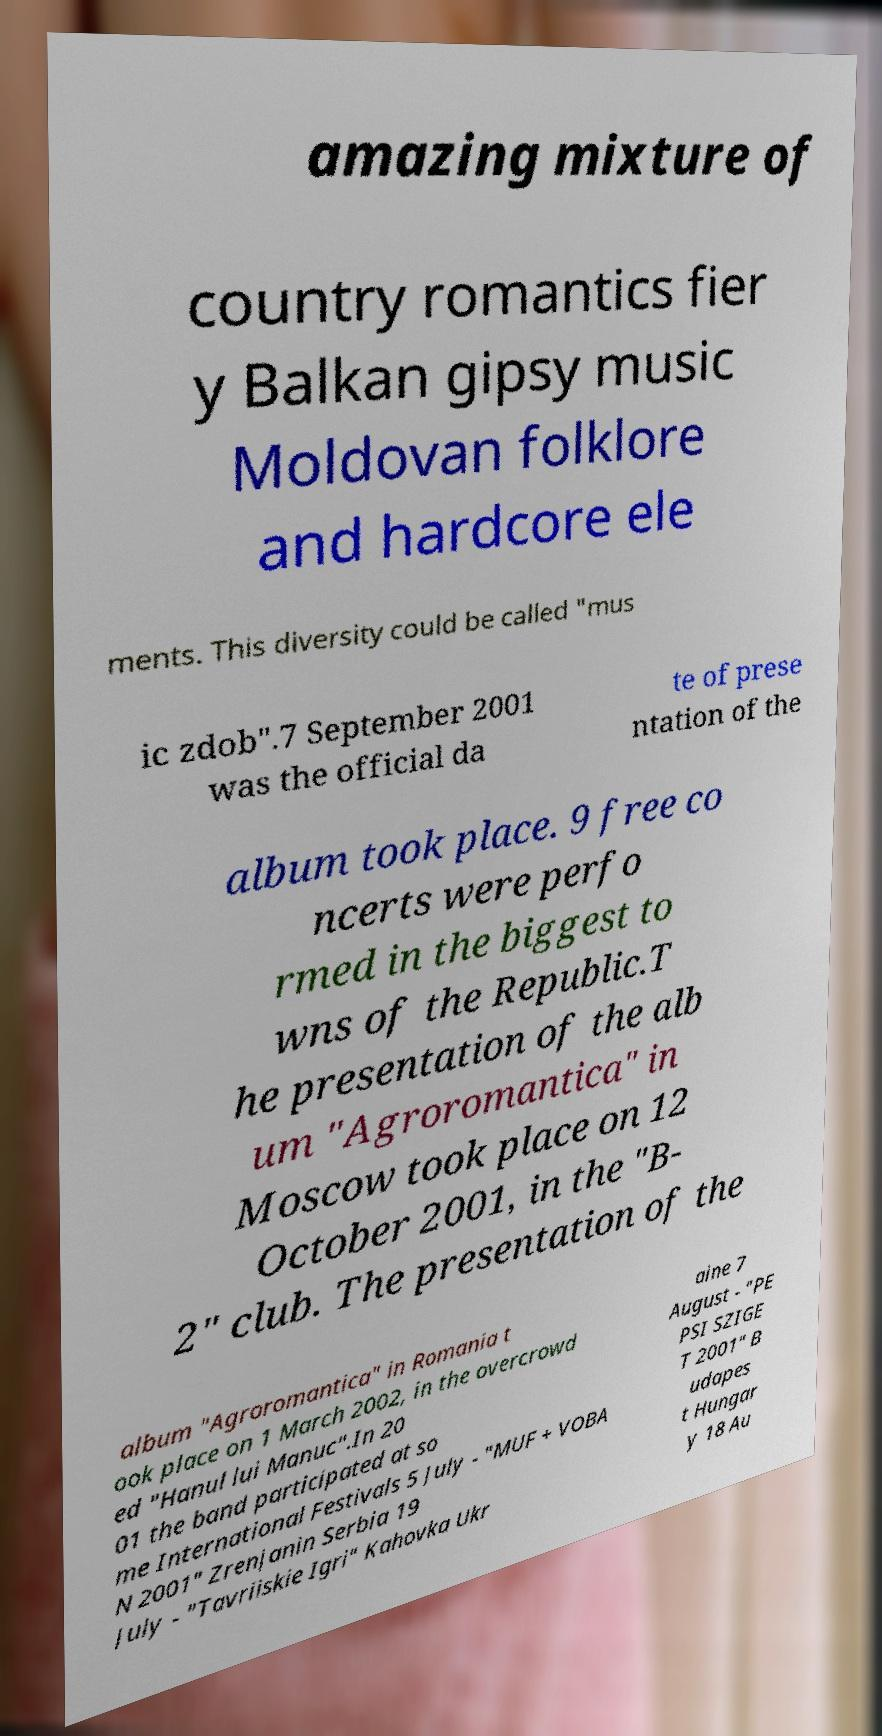Can you read and provide the text displayed in the image?This photo seems to have some interesting text. Can you extract and type it out for me? amazing mixture of country romantics fier y Balkan gipsy music Moldovan folklore and hardcore ele ments. This diversity could be called "mus ic zdob".7 September 2001 was the official da te of prese ntation of the album took place. 9 free co ncerts were perfo rmed in the biggest to wns of the Republic.T he presentation of the alb um "Agroromantica" in Moscow took place on 12 October 2001, in the "B- 2" club. The presentation of the album "Agroromantica" in Romania t ook place on 1 March 2002, in the overcrowd ed "Hanul lui Manuc".In 20 01 the band participated at so me International Festivals 5 July - "MUF + VOBA N 2001" Zrenjanin Serbia 19 July - "Tavriiskie Igri" Kahovka Ukr aine 7 August - "PE PSI SZIGE T 2001" B udapes t Hungar y 18 Au 